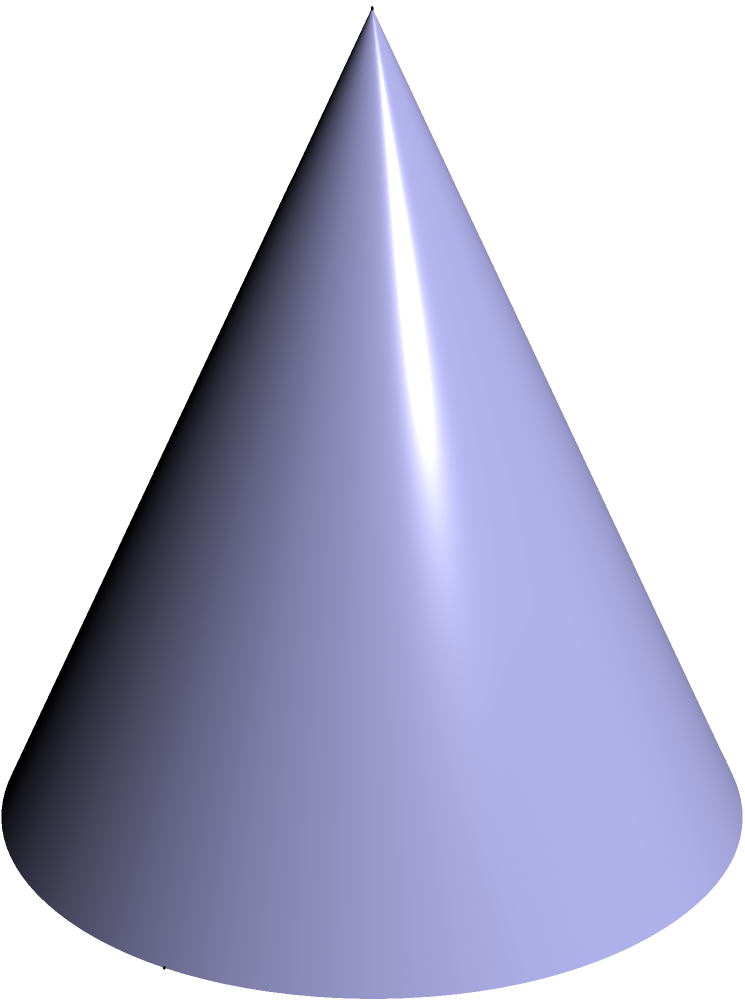A school is planning to install a conical water tank for their irrigation system. The tank has a height of 6 meters and a base radius of 3 meters. As an education policy advisor assessing digital solutions for educational outcomes, you need to calculate the volume of this tank to determine its capacity for supporting the school's water needs. What is the volume of the conical water tank in cubic meters? To find the volume of a cone, we use the formula:

$$V = \frac{1}{3}\pi r^2 h$$

Where:
$V$ = volume
$r$ = radius of the base
$h$ = height of the cone

Given:
$r = 3$ meters
$h = 6$ meters

Let's substitute these values into the formula:

$$V = \frac{1}{3}\pi (3\text{ m})^2 (6\text{ m})$$

$$V = \frac{1}{3}\pi (9\text{ m}^2) (6\text{ m})$$

$$V = 18\pi\text{ m}^3$$

Now, let's calculate the exact value:

$$V = 18 \times 3.14159...\text{ m}^3$$

$$V \approx 56.55\text{ m}^3$$

Therefore, the volume of the conical water tank is approximately 56.55 cubic meters.
Answer: $56.55\text{ m}^3$ 